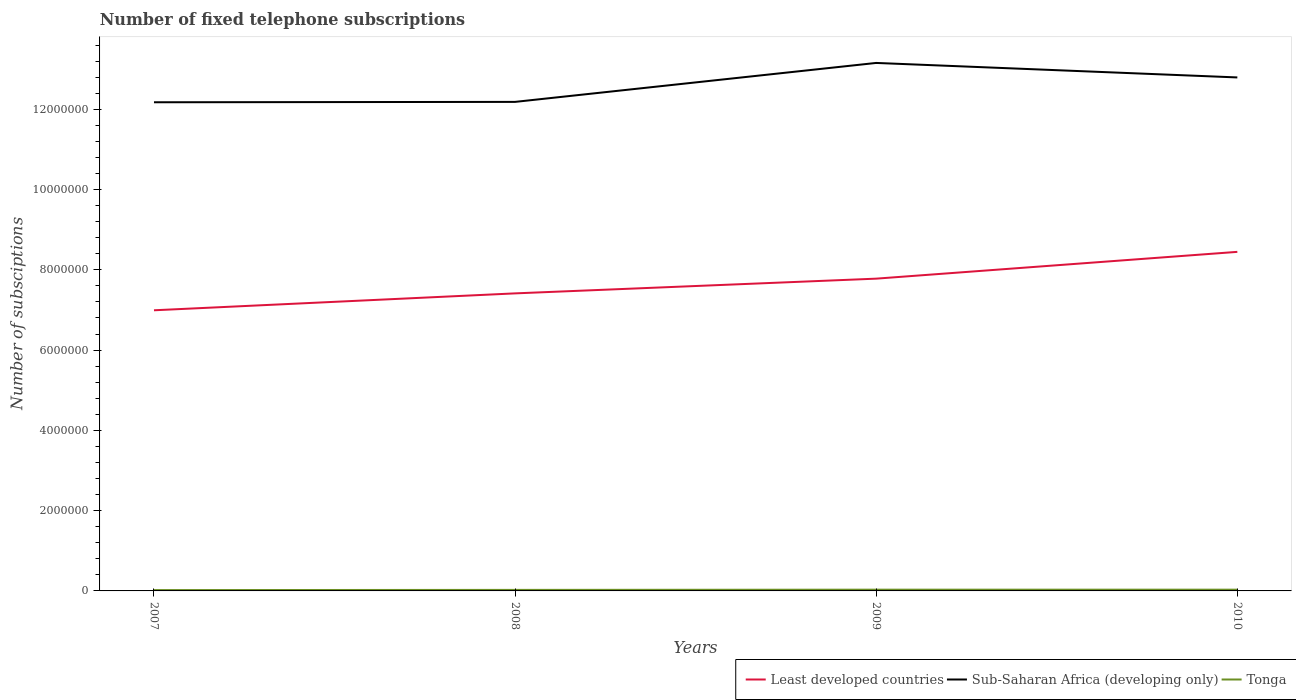Across all years, what is the maximum number of fixed telephone subscriptions in Least developed countries?
Offer a terse response. 6.99e+06. In which year was the number of fixed telephone subscriptions in Least developed countries maximum?
Ensure brevity in your answer.  2007. What is the total number of fixed telephone subscriptions in Tonga in the graph?
Provide a short and direct response. -9966. What is the difference between the highest and the second highest number of fixed telephone subscriptions in Tonga?
Make the answer very short. 9966. How many lines are there?
Offer a very short reply. 3. How many years are there in the graph?
Ensure brevity in your answer.  4. Does the graph contain any zero values?
Provide a short and direct response. No. Where does the legend appear in the graph?
Your response must be concise. Bottom right. What is the title of the graph?
Your response must be concise. Number of fixed telephone subscriptions. Does "Greece" appear as one of the legend labels in the graph?
Your answer should be very brief. No. What is the label or title of the Y-axis?
Give a very brief answer. Number of subsciptions. What is the Number of subsciptions in Least developed countries in 2007?
Your answer should be compact. 6.99e+06. What is the Number of subsciptions in Sub-Saharan Africa (developing only) in 2007?
Make the answer very short. 1.22e+07. What is the Number of subsciptions of Tonga in 2007?
Your response must be concise. 2.10e+04. What is the Number of subsciptions of Least developed countries in 2008?
Ensure brevity in your answer.  7.41e+06. What is the Number of subsciptions of Sub-Saharan Africa (developing only) in 2008?
Provide a succinct answer. 1.22e+07. What is the Number of subsciptions in Tonga in 2008?
Your response must be concise. 2.55e+04. What is the Number of subsciptions of Least developed countries in 2009?
Make the answer very short. 7.78e+06. What is the Number of subsciptions in Sub-Saharan Africa (developing only) in 2009?
Make the answer very short. 1.32e+07. What is the Number of subsciptions of Tonga in 2009?
Offer a very short reply. 3.10e+04. What is the Number of subsciptions in Least developed countries in 2010?
Give a very brief answer. 8.45e+06. What is the Number of subsciptions in Sub-Saharan Africa (developing only) in 2010?
Make the answer very short. 1.28e+07. What is the Number of subsciptions in Tonga in 2010?
Your answer should be very brief. 3.10e+04. Across all years, what is the maximum Number of subsciptions in Least developed countries?
Ensure brevity in your answer.  8.45e+06. Across all years, what is the maximum Number of subsciptions of Sub-Saharan Africa (developing only)?
Provide a short and direct response. 1.32e+07. Across all years, what is the maximum Number of subsciptions in Tonga?
Provide a short and direct response. 3.10e+04. Across all years, what is the minimum Number of subsciptions of Least developed countries?
Offer a very short reply. 6.99e+06. Across all years, what is the minimum Number of subsciptions of Sub-Saharan Africa (developing only)?
Provide a short and direct response. 1.22e+07. Across all years, what is the minimum Number of subsciptions of Tonga?
Your answer should be very brief. 2.10e+04. What is the total Number of subsciptions of Least developed countries in the graph?
Make the answer very short. 3.06e+07. What is the total Number of subsciptions of Sub-Saharan Africa (developing only) in the graph?
Offer a very short reply. 5.03e+07. What is the total Number of subsciptions of Tonga in the graph?
Offer a terse response. 1.09e+05. What is the difference between the Number of subsciptions of Least developed countries in 2007 and that in 2008?
Offer a very short reply. -4.21e+05. What is the difference between the Number of subsciptions of Sub-Saharan Africa (developing only) in 2007 and that in 2008?
Keep it short and to the point. -9445. What is the difference between the Number of subsciptions in Tonga in 2007 and that in 2008?
Your answer should be compact. -4502. What is the difference between the Number of subsciptions of Least developed countries in 2007 and that in 2009?
Offer a very short reply. -7.88e+05. What is the difference between the Number of subsciptions in Sub-Saharan Africa (developing only) in 2007 and that in 2009?
Your answer should be compact. -9.80e+05. What is the difference between the Number of subsciptions in Tonga in 2007 and that in 2009?
Offer a very short reply. -9966. What is the difference between the Number of subsciptions of Least developed countries in 2007 and that in 2010?
Provide a succinct answer. -1.46e+06. What is the difference between the Number of subsciptions of Sub-Saharan Africa (developing only) in 2007 and that in 2010?
Your answer should be compact. -6.18e+05. What is the difference between the Number of subsciptions of Tonga in 2007 and that in 2010?
Your answer should be compact. -9966. What is the difference between the Number of subsciptions of Least developed countries in 2008 and that in 2009?
Your response must be concise. -3.67e+05. What is the difference between the Number of subsciptions of Sub-Saharan Africa (developing only) in 2008 and that in 2009?
Ensure brevity in your answer.  -9.70e+05. What is the difference between the Number of subsciptions in Tonga in 2008 and that in 2009?
Your response must be concise. -5464. What is the difference between the Number of subsciptions of Least developed countries in 2008 and that in 2010?
Your answer should be very brief. -1.03e+06. What is the difference between the Number of subsciptions in Sub-Saharan Africa (developing only) in 2008 and that in 2010?
Offer a terse response. -6.09e+05. What is the difference between the Number of subsciptions in Tonga in 2008 and that in 2010?
Offer a very short reply. -5464. What is the difference between the Number of subsciptions of Least developed countries in 2009 and that in 2010?
Ensure brevity in your answer.  -6.67e+05. What is the difference between the Number of subsciptions of Sub-Saharan Africa (developing only) in 2009 and that in 2010?
Provide a short and direct response. 3.61e+05. What is the difference between the Number of subsciptions of Tonga in 2009 and that in 2010?
Offer a very short reply. 0. What is the difference between the Number of subsciptions of Least developed countries in 2007 and the Number of subsciptions of Sub-Saharan Africa (developing only) in 2008?
Your answer should be compact. -5.19e+06. What is the difference between the Number of subsciptions of Least developed countries in 2007 and the Number of subsciptions of Tonga in 2008?
Ensure brevity in your answer.  6.97e+06. What is the difference between the Number of subsciptions of Sub-Saharan Africa (developing only) in 2007 and the Number of subsciptions of Tonga in 2008?
Provide a short and direct response. 1.21e+07. What is the difference between the Number of subsciptions of Least developed countries in 2007 and the Number of subsciptions of Sub-Saharan Africa (developing only) in 2009?
Your response must be concise. -6.16e+06. What is the difference between the Number of subsciptions of Least developed countries in 2007 and the Number of subsciptions of Tonga in 2009?
Give a very brief answer. 6.96e+06. What is the difference between the Number of subsciptions in Sub-Saharan Africa (developing only) in 2007 and the Number of subsciptions in Tonga in 2009?
Your answer should be very brief. 1.21e+07. What is the difference between the Number of subsciptions of Least developed countries in 2007 and the Number of subsciptions of Sub-Saharan Africa (developing only) in 2010?
Your response must be concise. -5.80e+06. What is the difference between the Number of subsciptions of Least developed countries in 2007 and the Number of subsciptions of Tonga in 2010?
Your answer should be very brief. 6.96e+06. What is the difference between the Number of subsciptions of Sub-Saharan Africa (developing only) in 2007 and the Number of subsciptions of Tonga in 2010?
Ensure brevity in your answer.  1.21e+07. What is the difference between the Number of subsciptions in Least developed countries in 2008 and the Number of subsciptions in Sub-Saharan Africa (developing only) in 2009?
Give a very brief answer. -5.74e+06. What is the difference between the Number of subsciptions in Least developed countries in 2008 and the Number of subsciptions in Tonga in 2009?
Ensure brevity in your answer.  7.38e+06. What is the difference between the Number of subsciptions of Sub-Saharan Africa (developing only) in 2008 and the Number of subsciptions of Tonga in 2009?
Your answer should be very brief. 1.22e+07. What is the difference between the Number of subsciptions in Least developed countries in 2008 and the Number of subsciptions in Sub-Saharan Africa (developing only) in 2010?
Your answer should be very brief. -5.38e+06. What is the difference between the Number of subsciptions in Least developed countries in 2008 and the Number of subsciptions in Tonga in 2010?
Make the answer very short. 7.38e+06. What is the difference between the Number of subsciptions in Sub-Saharan Africa (developing only) in 2008 and the Number of subsciptions in Tonga in 2010?
Your response must be concise. 1.22e+07. What is the difference between the Number of subsciptions of Least developed countries in 2009 and the Number of subsciptions of Sub-Saharan Africa (developing only) in 2010?
Your answer should be compact. -5.01e+06. What is the difference between the Number of subsciptions in Least developed countries in 2009 and the Number of subsciptions in Tonga in 2010?
Make the answer very short. 7.75e+06. What is the difference between the Number of subsciptions of Sub-Saharan Africa (developing only) in 2009 and the Number of subsciptions of Tonga in 2010?
Provide a succinct answer. 1.31e+07. What is the average Number of subsciptions in Least developed countries per year?
Keep it short and to the point. 7.66e+06. What is the average Number of subsciptions of Sub-Saharan Africa (developing only) per year?
Offer a terse response. 1.26e+07. What is the average Number of subsciptions of Tonga per year?
Provide a short and direct response. 2.71e+04. In the year 2007, what is the difference between the Number of subsciptions in Least developed countries and Number of subsciptions in Sub-Saharan Africa (developing only)?
Give a very brief answer. -5.18e+06. In the year 2007, what is the difference between the Number of subsciptions of Least developed countries and Number of subsciptions of Tonga?
Make the answer very short. 6.97e+06. In the year 2007, what is the difference between the Number of subsciptions in Sub-Saharan Africa (developing only) and Number of subsciptions in Tonga?
Your answer should be compact. 1.22e+07. In the year 2008, what is the difference between the Number of subsciptions of Least developed countries and Number of subsciptions of Sub-Saharan Africa (developing only)?
Ensure brevity in your answer.  -4.77e+06. In the year 2008, what is the difference between the Number of subsciptions in Least developed countries and Number of subsciptions in Tonga?
Make the answer very short. 7.39e+06. In the year 2008, what is the difference between the Number of subsciptions of Sub-Saharan Africa (developing only) and Number of subsciptions of Tonga?
Your answer should be very brief. 1.22e+07. In the year 2009, what is the difference between the Number of subsciptions of Least developed countries and Number of subsciptions of Sub-Saharan Africa (developing only)?
Ensure brevity in your answer.  -5.37e+06. In the year 2009, what is the difference between the Number of subsciptions of Least developed countries and Number of subsciptions of Tonga?
Make the answer very short. 7.75e+06. In the year 2009, what is the difference between the Number of subsciptions in Sub-Saharan Africa (developing only) and Number of subsciptions in Tonga?
Provide a short and direct response. 1.31e+07. In the year 2010, what is the difference between the Number of subsciptions of Least developed countries and Number of subsciptions of Sub-Saharan Africa (developing only)?
Give a very brief answer. -4.35e+06. In the year 2010, what is the difference between the Number of subsciptions of Least developed countries and Number of subsciptions of Tonga?
Offer a terse response. 8.42e+06. In the year 2010, what is the difference between the Number of subsciptions in Sub-Saharan Africa (developing only) and Number of subsciptions in Tonga?
Your answer should be compact. 1.28e+07. What is the ratio of the Number of subsciptions of Least developed countries in 2007 to that in 2008?
Provide a short and direct response. 0.94. What is the ratio of the Number of subsciptions of Sub-Saharan Africa (developing only) in 2007 to that in 2008?
Your answer should be compact. 1. What is the ratio of the Number of subsciptions in Tonga in 2007 to that in 2008?
Provide a succinct answer. 0.82. What is the ratio of the Number of subsciptions in Least developed countries in 2007 to that in 2009?
Offer a very short reply. 0.9. What is the ratio of the Number of subsciptions of Sub-Saharan Africa (developing only) in 2007 to that in 2009?
Offer a very short reply. 0.93. What is the ratio of the Number of subsciptions of Tonga in 2007 to that in 2009?
Your answer should be very brief. 0.68. What is the ratio of the Number of subsciptions in Least developed countries in 2007 to that in 2010?
Provide a short and direct response. 0.83. What is the ratio of the Number of subsciptions of Sub-Saharan Africa (developing only) in 2007 to that in 2010?
Offer a very short reply. 0.95. What is the ratio of the Number of subsciptions of Tonga in 2007 to that in 2010?
Keep it short and to the point. 0.68. What is the ratio of the Number of subsciptions in Least developed countries in 2008 to that in 2009?
Provide a succinct answer. 0.95. What is the ratio of the Number of subsciptions of Sub-Saharan Africa (developing only) in 2008 to that in 2009?
Make the answer very short. 0.93. What is the ratio of the Number of subsciptions in Tonga in 2008 to that in 2009?
Provide a succinct answer. 0.82. What is the ratio of the Number of subsciptions in Least developed countries in 2008 to that in 2010?
Provide a short and direct response. 0.88. What is the ratio of the Number of subsciptions of Tonga in 2008 to that in 2010?
Your answer should be very brief. 0.82. What is the ratio of the Number of subsciptions in Least developed countries in 2009 to that in 2010?
Give a very brief answer. 0.92. What is the ratio of the Number of subsciptions of Sub-Saharan Africa (developing only) in 2009 to that in 2010?
Give a very brief answer. 1.03. What is the ratio of the Number of subsciptions in Tonga in 2009 to that in 2010?
Keep it short and to the point. 1. What is the difference between the highest and the second highest Number of subsciptions of Least developed countries?
Offer a terse response. 6.67e+05. What is the difference between the highest and the second highest Number of subsciptions of Sub-Saharan Africa (developing only)?
Your answer should be compact. 3.61e+05. What is the difference between the highest and the second highest Number of subsciptions of Tonga?
Your response must be concise. 0. What is the difference between the highest and the lowest Number of subsciptions of Least developed countries?
Make the answer very short. 1.46e+06. What is the difference between the highest and the lowest Number of subsciptions of Sub-Saharan Africa (developing only)?
Offer a very short reply. 9.80e+05. What is the difference between the highest and the lowest Number of subsciptions in Tonga?
Ensure brevity in your answer.  9966. 